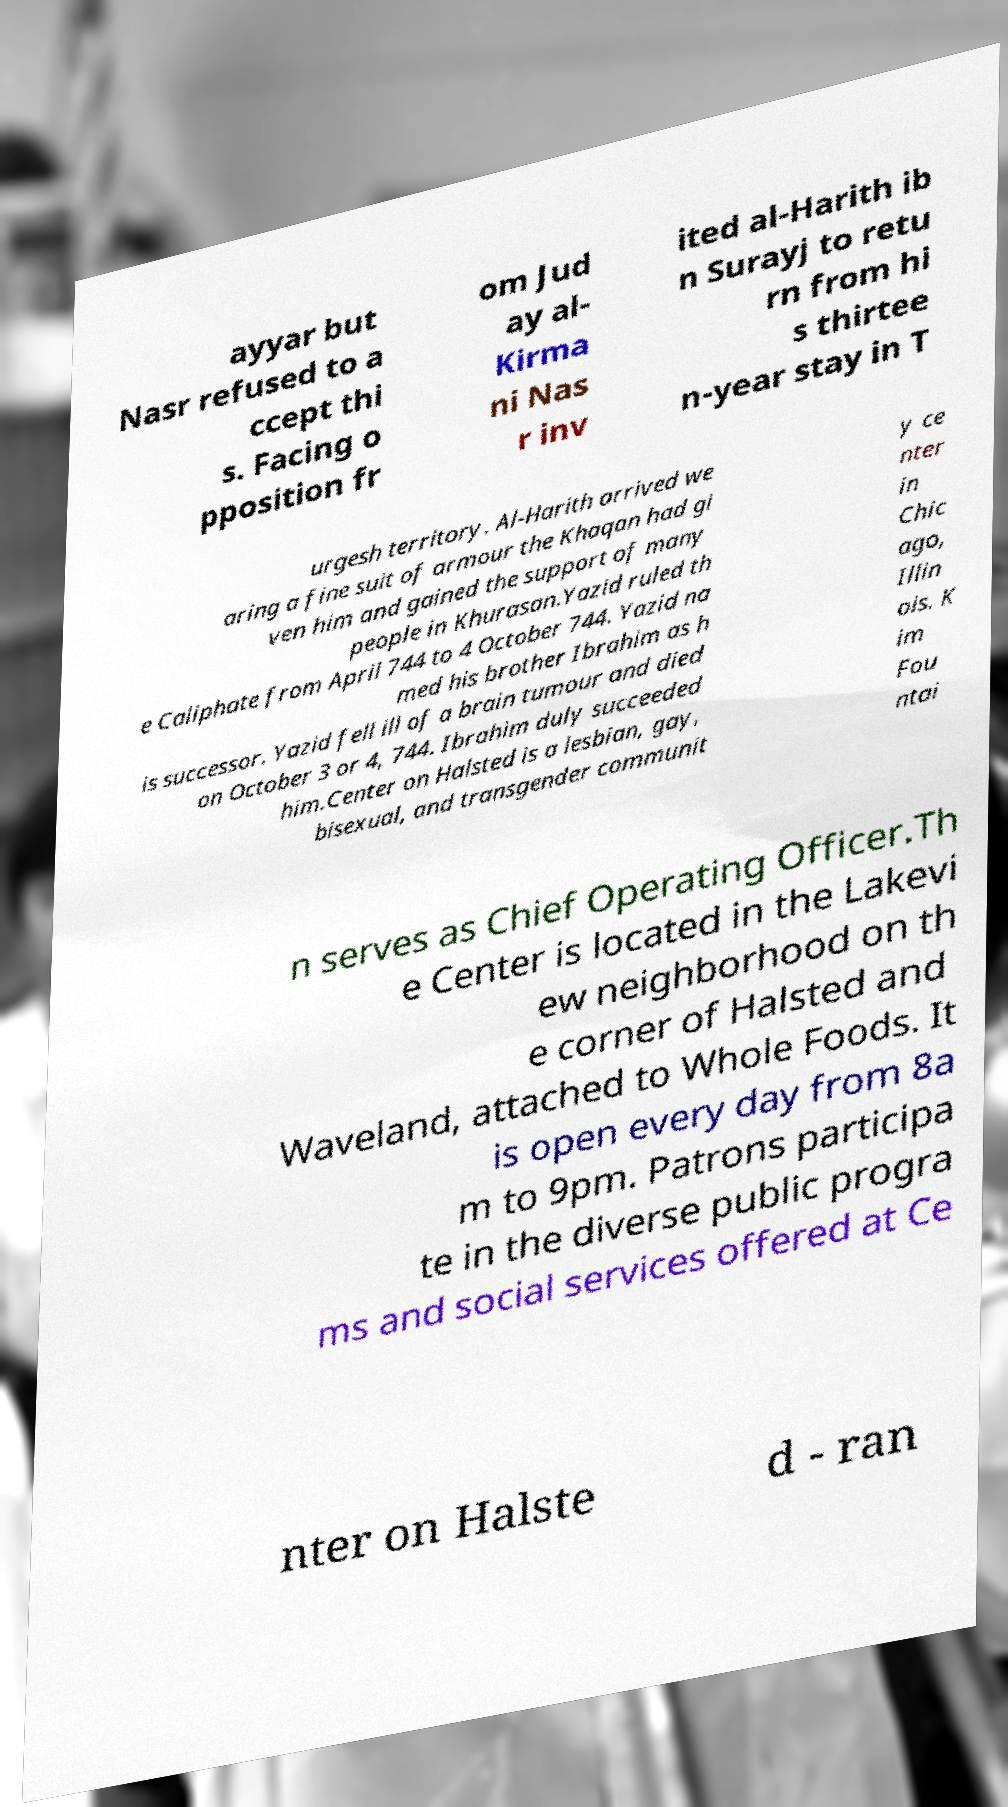I need the written content from this picture converted into text. Can you do that? ayyar but Nasr refused to a ccept thi s. Facing o pposition fr om Jud ay al- Kirma ni Nas r inv ited al-Harith ib n Surayj to retu rn from hi s thirtee n-year stay in T urgesh territory. Al-Harith arrived we aring a fine suit of armour the Khaqan had gi ven him and gained the support of many people in Khurasan.Yazid ruled th e Caliphate from April 744 to 4 October 744. Yazid na med his brother Ibrahim as h is successor. Yazid fell ill of a brain tumour and died on October 3 or 4, 744. Ibrahim duly succeeded him.Center on Halsted is a lesbian, gay, bisexual, and transgender communit y ce nter in Chic ago, Illin ois. K im Fou ntai n serves as Chief Operating Officer.Th e Center is located in the Lakevi ew neighborhood on th e corner of Halsted and Waveland, attached to Whole Foods. It is open every day from 8a m to 9pm. Patrons participa te in the diverse public progra ms and social services offered at Ce nter on Halste d - ran 